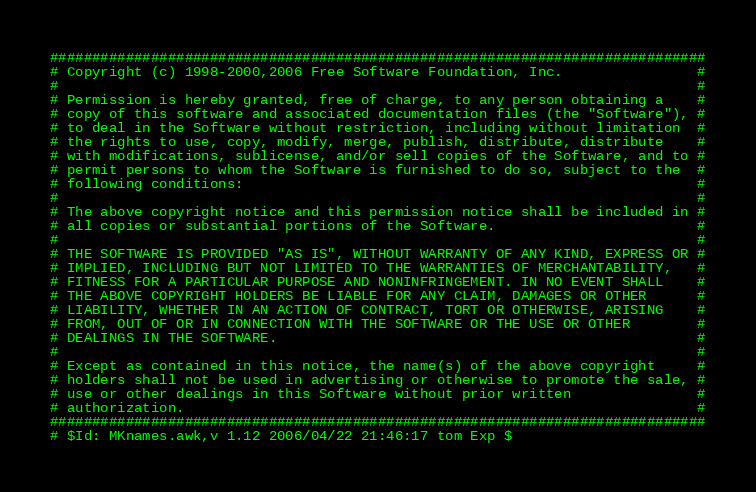<code> <loc_0><loc_0><loc_500><loc_500><_Awk_>##############################################################################
# Copyright (c) 1998-2000,2006 Free Software Foundation, Inc.                #
#                                                                            #
# Permission is hereby granted, free of charge, to any person obtaining a    #
# copy of this software and associated documentation files (the "Software"), #
# to deal in the Software without restriction, including without limitation  #
# the rights to use, copy, modify, merge, publish, distribute, distribute    #
# with modifications, sublicense, and/or sell copies of the Software, and to #
# permit persons to whom the Software is furnished to do so, subject to the  #
# following conditions:                                                      #
#                                                                            #
# The above copyright notice and this permission notice shall be included in #
# all copies or substantial portions of the Software.                        #
#                                                                            #
# THE SOFTWARE IS PROVIDED "AS IS", WITHOUT WARRANTY OF ANY KIND, EXPRESS OR #
# IMPLIED, INCLUDING BUT NOT LIMITED TO THE WARRANTIES OF MERCHANTABILITY,   #
# FITNESS FOR A PARTICULAR PURPOSE AND NONINFRINGEMENT. IN NO EVENT SHALL    #
# THE ABOVE COPYRIGHT HOLDERS BE LIABLE FOR ANY CLAIM, DAMAGES OR OTHER      #
# LIABILITY, WHETHER IN AN ACTION OF CONTRACT, TORT OR OTHERWISE, ARISING    #
# FROM, OUT OF OR IN CONNECTION WITH THE SOFTWARE OR THE USE OR OTHER        #
# DEALINGS IN THE SOFTWARE.                                                  #
#                                                                            #
# Except as contained in this notice, the name(s) of the above copyright     #
# holders shall not be used in advertising or otherwise to promote the sale, #
# use or other dealings in this Software without prior written               #
# authorization.                                                             #
##############################################################################
# $Id: MKnames.awk,v 1.12 2006/04/22 21:46:17 tom Exp $</code> 